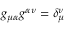Convert formula to latex. <formula><loc_0><loc_0><loc_500><loc_500>g _ { \mu \alpha } g ^ { \alpha \nu } = \delta _ { \mu } ^ { \nu }</formula> 